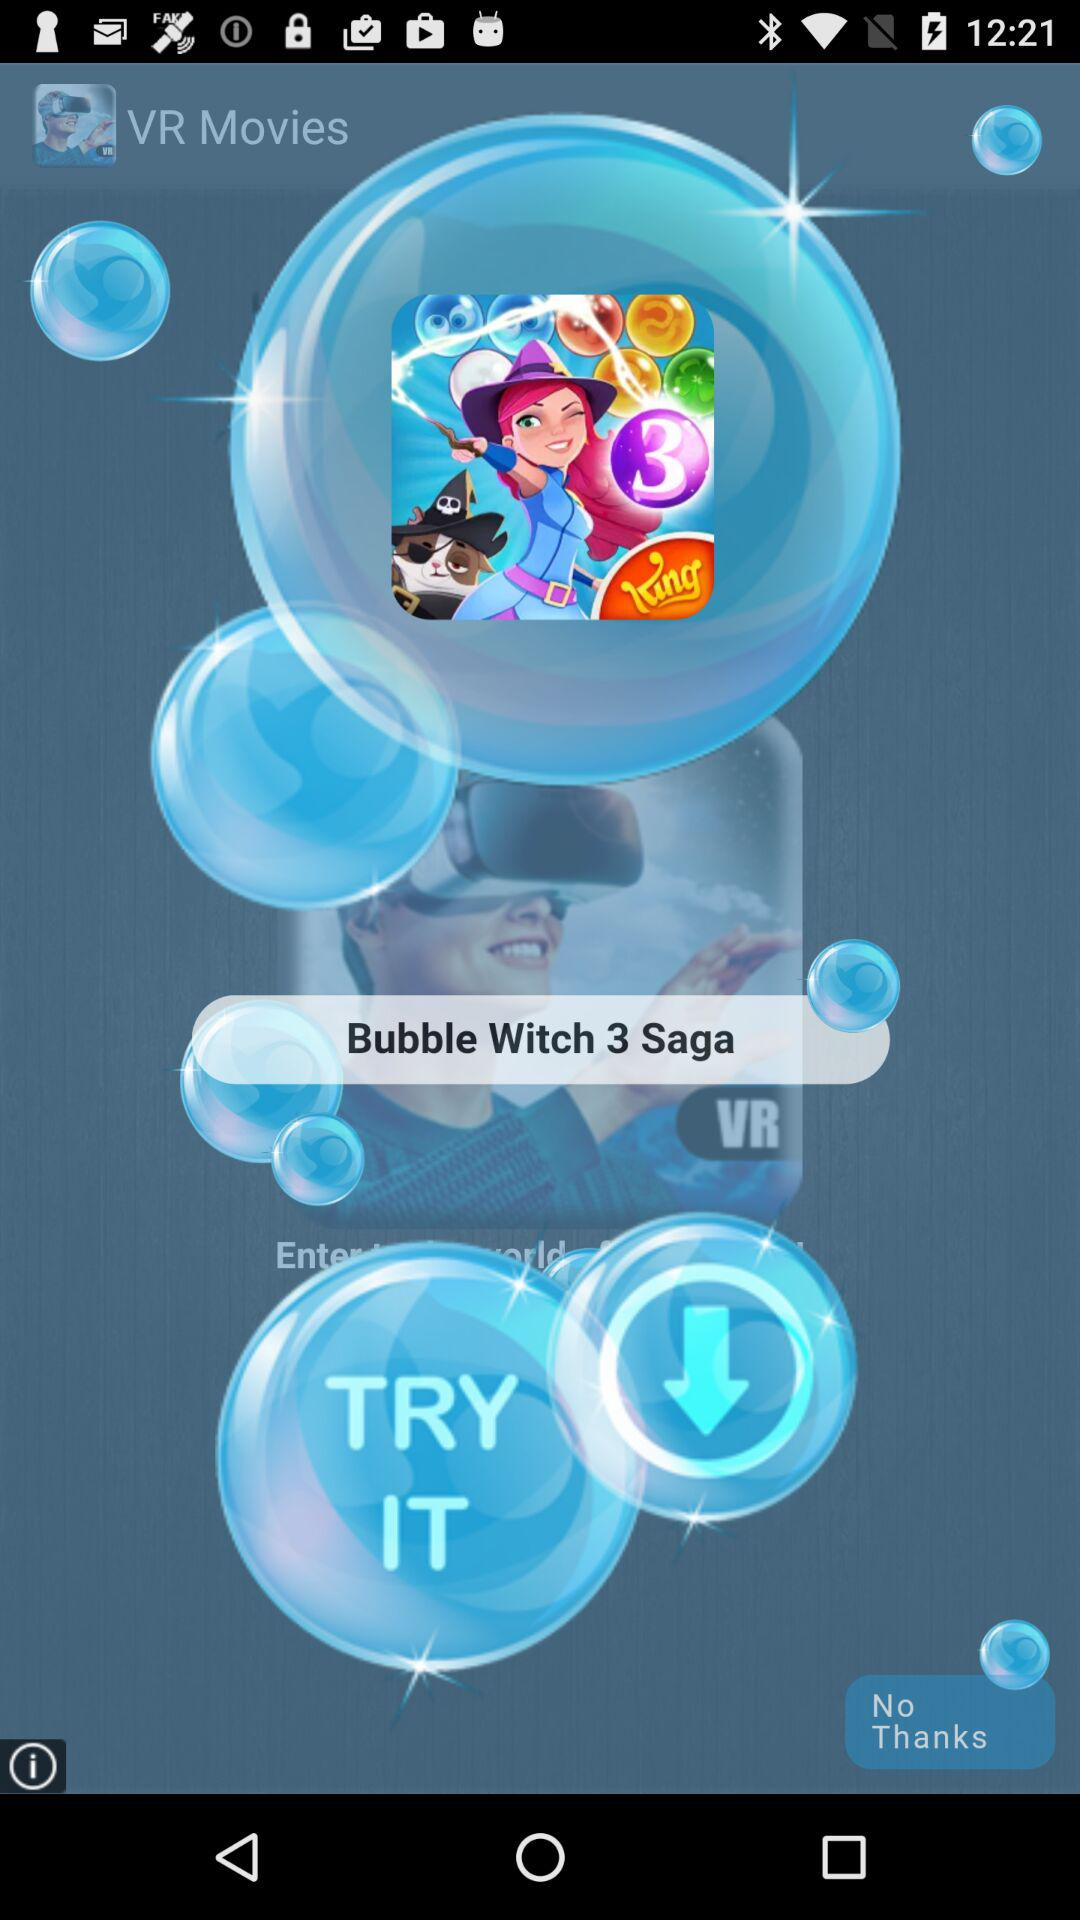What is the application name? The application name is "VR Movies". 